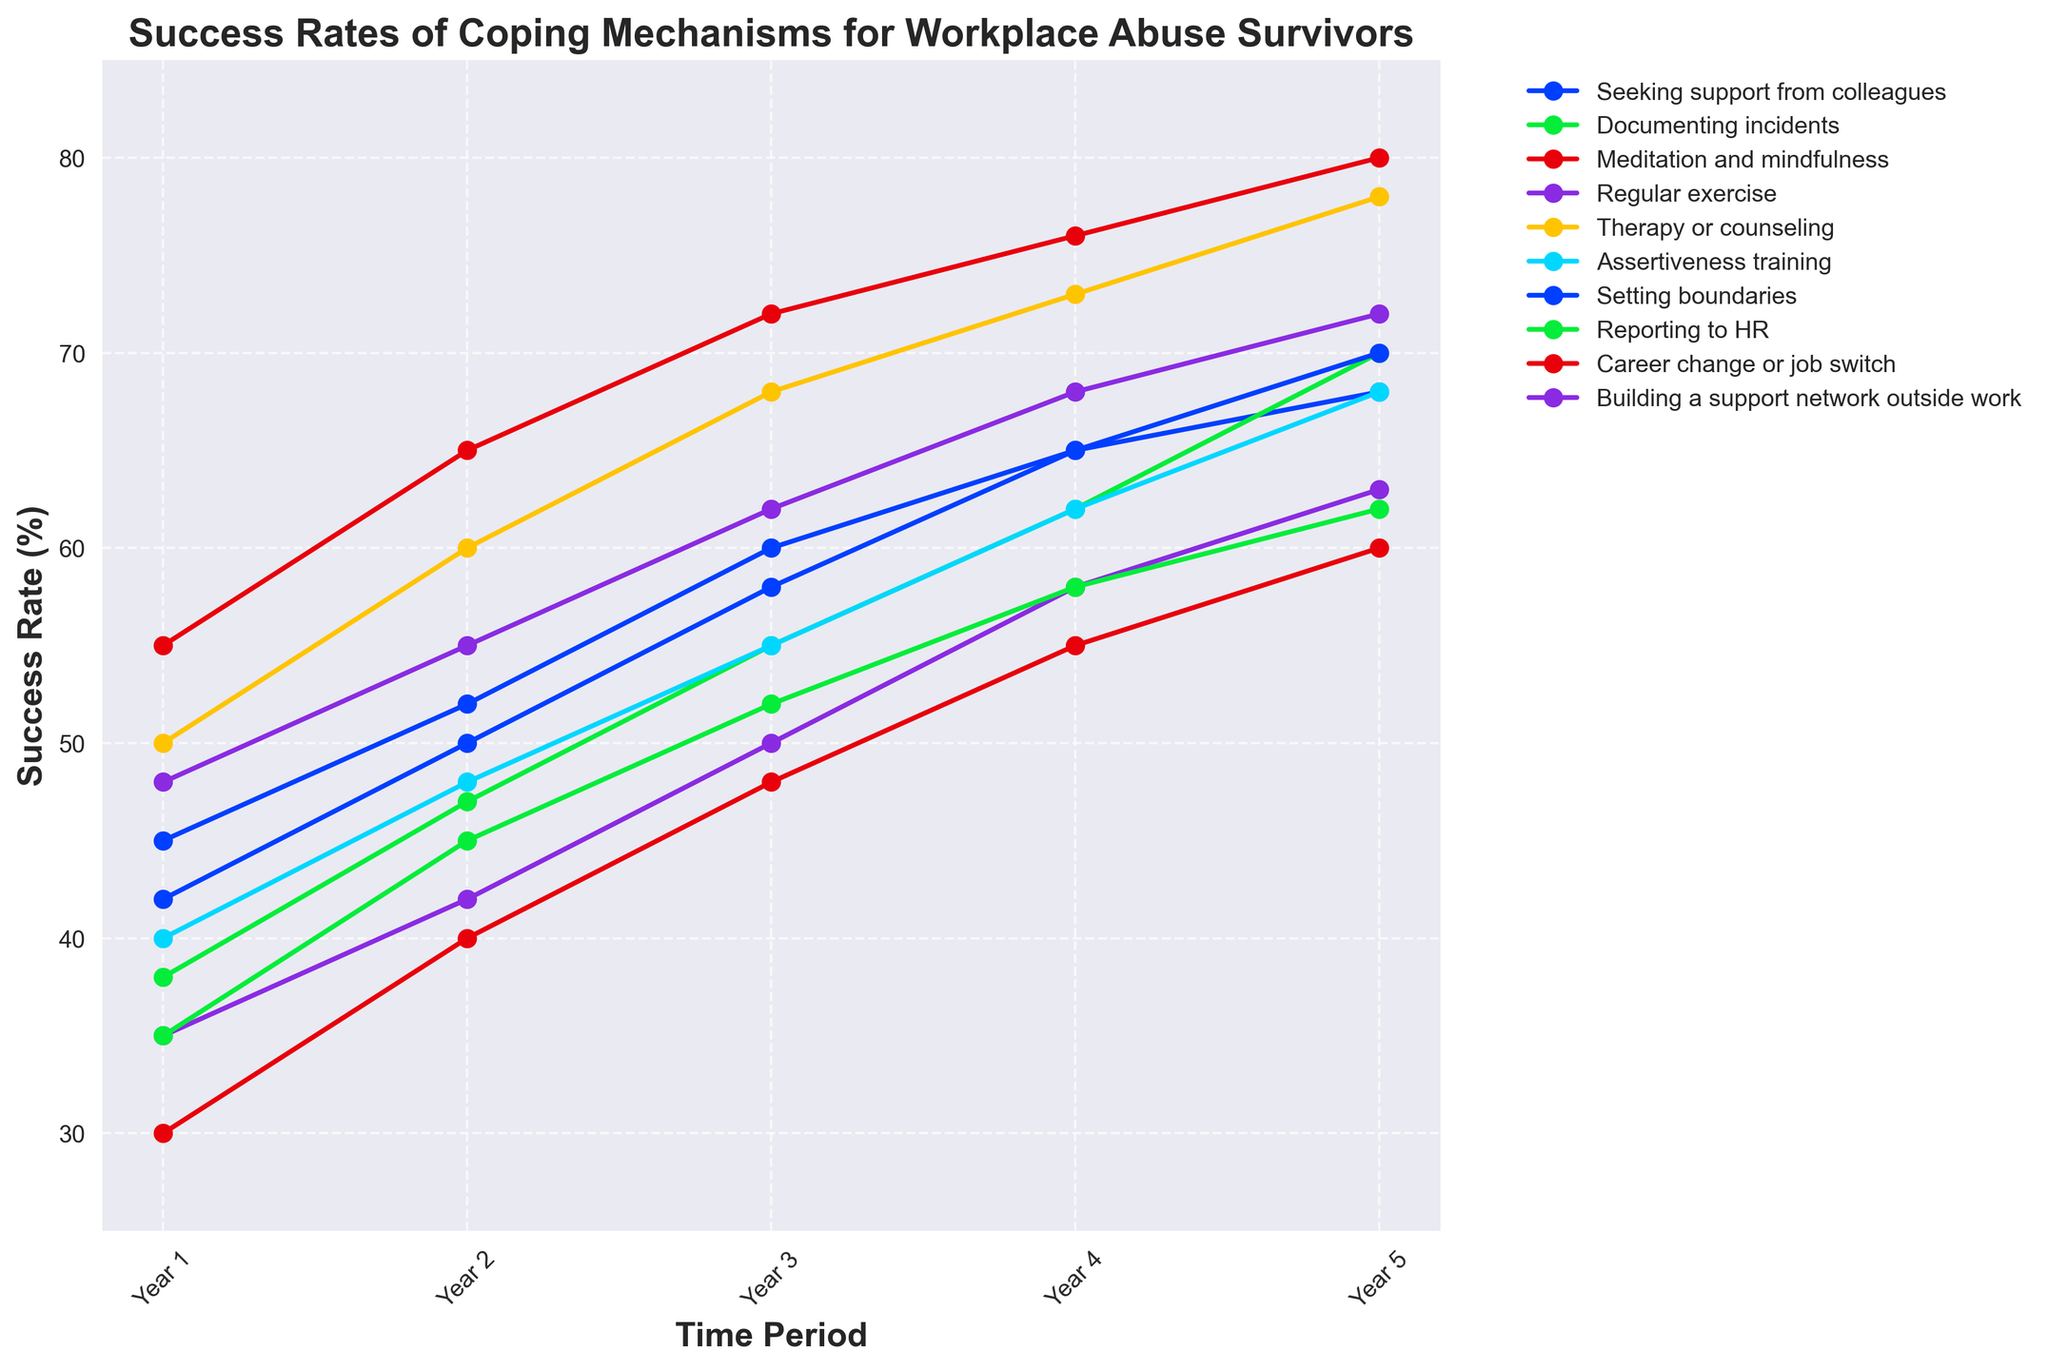Which coping mechanism saw the highest success rate by Year 5? By looking at Year 5 data points, the highest success rate is seen for 'Career change or job switch' which ends at a success rate of 80%.
Answer: Career change or job switch How did the success rate of 'Therapy or counseling' change over the 5-year period? The initial success rate for 'Therapy or counseling' was 50%. Over 5 years, it increased to 60, then 68, 73, and finally 78. Thus, it shows a consistent positive trend.
Answer: Increased consistently What's the average success rate of 'Regular exercise' across all years? To find the average, sum the success rates for 'Regular exercise' (35 + 42 + 50 + 58 + 63) which equals 248, and divide by the number of years (5). The average is 248/5 which equals approximately 49.6.
Answer: 49.6 Which coping mechanism showed the largest increase in success rate from Year 1 to Year 5? Subtract the Year 1 rates from Year 5 rates for all mechanisms. 'Career change or job switch' goes from 55 to 80, an increase of 25, which is the largest increase.
Answer: Career change or job switch Compare the success rates of 'Meditation and mindfulness' and 'Assertiveness training' in Year 3. Which is higher? In Year 3, 'Meditation and mindfulness' has a success rate of 48 and 'Assertiveness training' has 55. Since 55 > 48, 'Assertiveness training' has a higher success rate.
Answer: Assertiveness training What is the difference in the success rate between 'Seeking support from colleagues' and 'Documenting incidents' in Year 5? For Year 5, 'Seeking support from colleagues' has a success rate of 68, and 'Documenting incidents' has a success rate of 70. The difference is 70 - 68 = 2.
Answer: 2 Which coping mechanism had a success rate below 40% in the first year, and how did it improve by the final year? In Year 1, 'Meditation and mindfulness' started at 30%. By Year 5, it improved to 60%. Therefore, it saw consistent growth from below 40% to 60%.
Answer: Meditation and mindfulness; improved to 60% For 'Reporting to HR', compare its trend to that of 'Career change or job switch'. How does their success rate progression over 5 years differ? 'Reporting to HR' starts at 35% and ends at 62%, showing a moderate increase. 'Career change or job switch' starts at 55% and ends at 80%, showing a steep increase.
Answer: 'Career change or job switch' has a steeper increase How did the success rates for 'Building a support network outside work' change from Year 3 to Year 5? Between Year 3 and Year 5, the success rates for 'Building a support network outside work' changed from 62 in Year 3 to 68 in Year 4 and finally to 72 in Year 5, indicating a steady increase.
Answer: Steady increase 